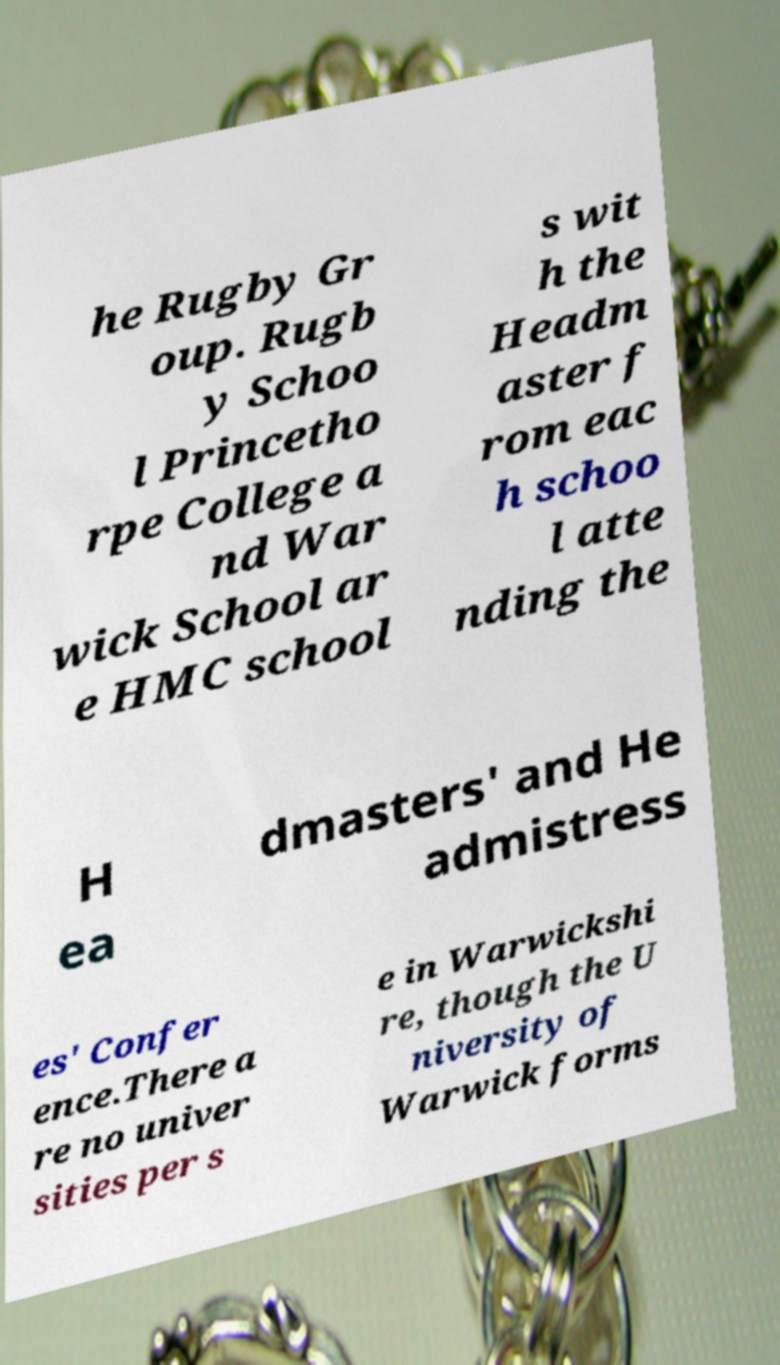Can you read and provide the text displayed in the image?This photo seems to have some interesting text. Can you extract and type it out for me? he Rugby Gr oup. Rugb y Schoo l Princetho rpe College a nd War wick School ar e HMC school s wit h the Headm aster f rom eac h schoo l atte nding the H ea dmasters' and He admistress es' Confer ence.There a re no univer sities per s e in Warwickshi re, though the U niversity of Warwick forms 